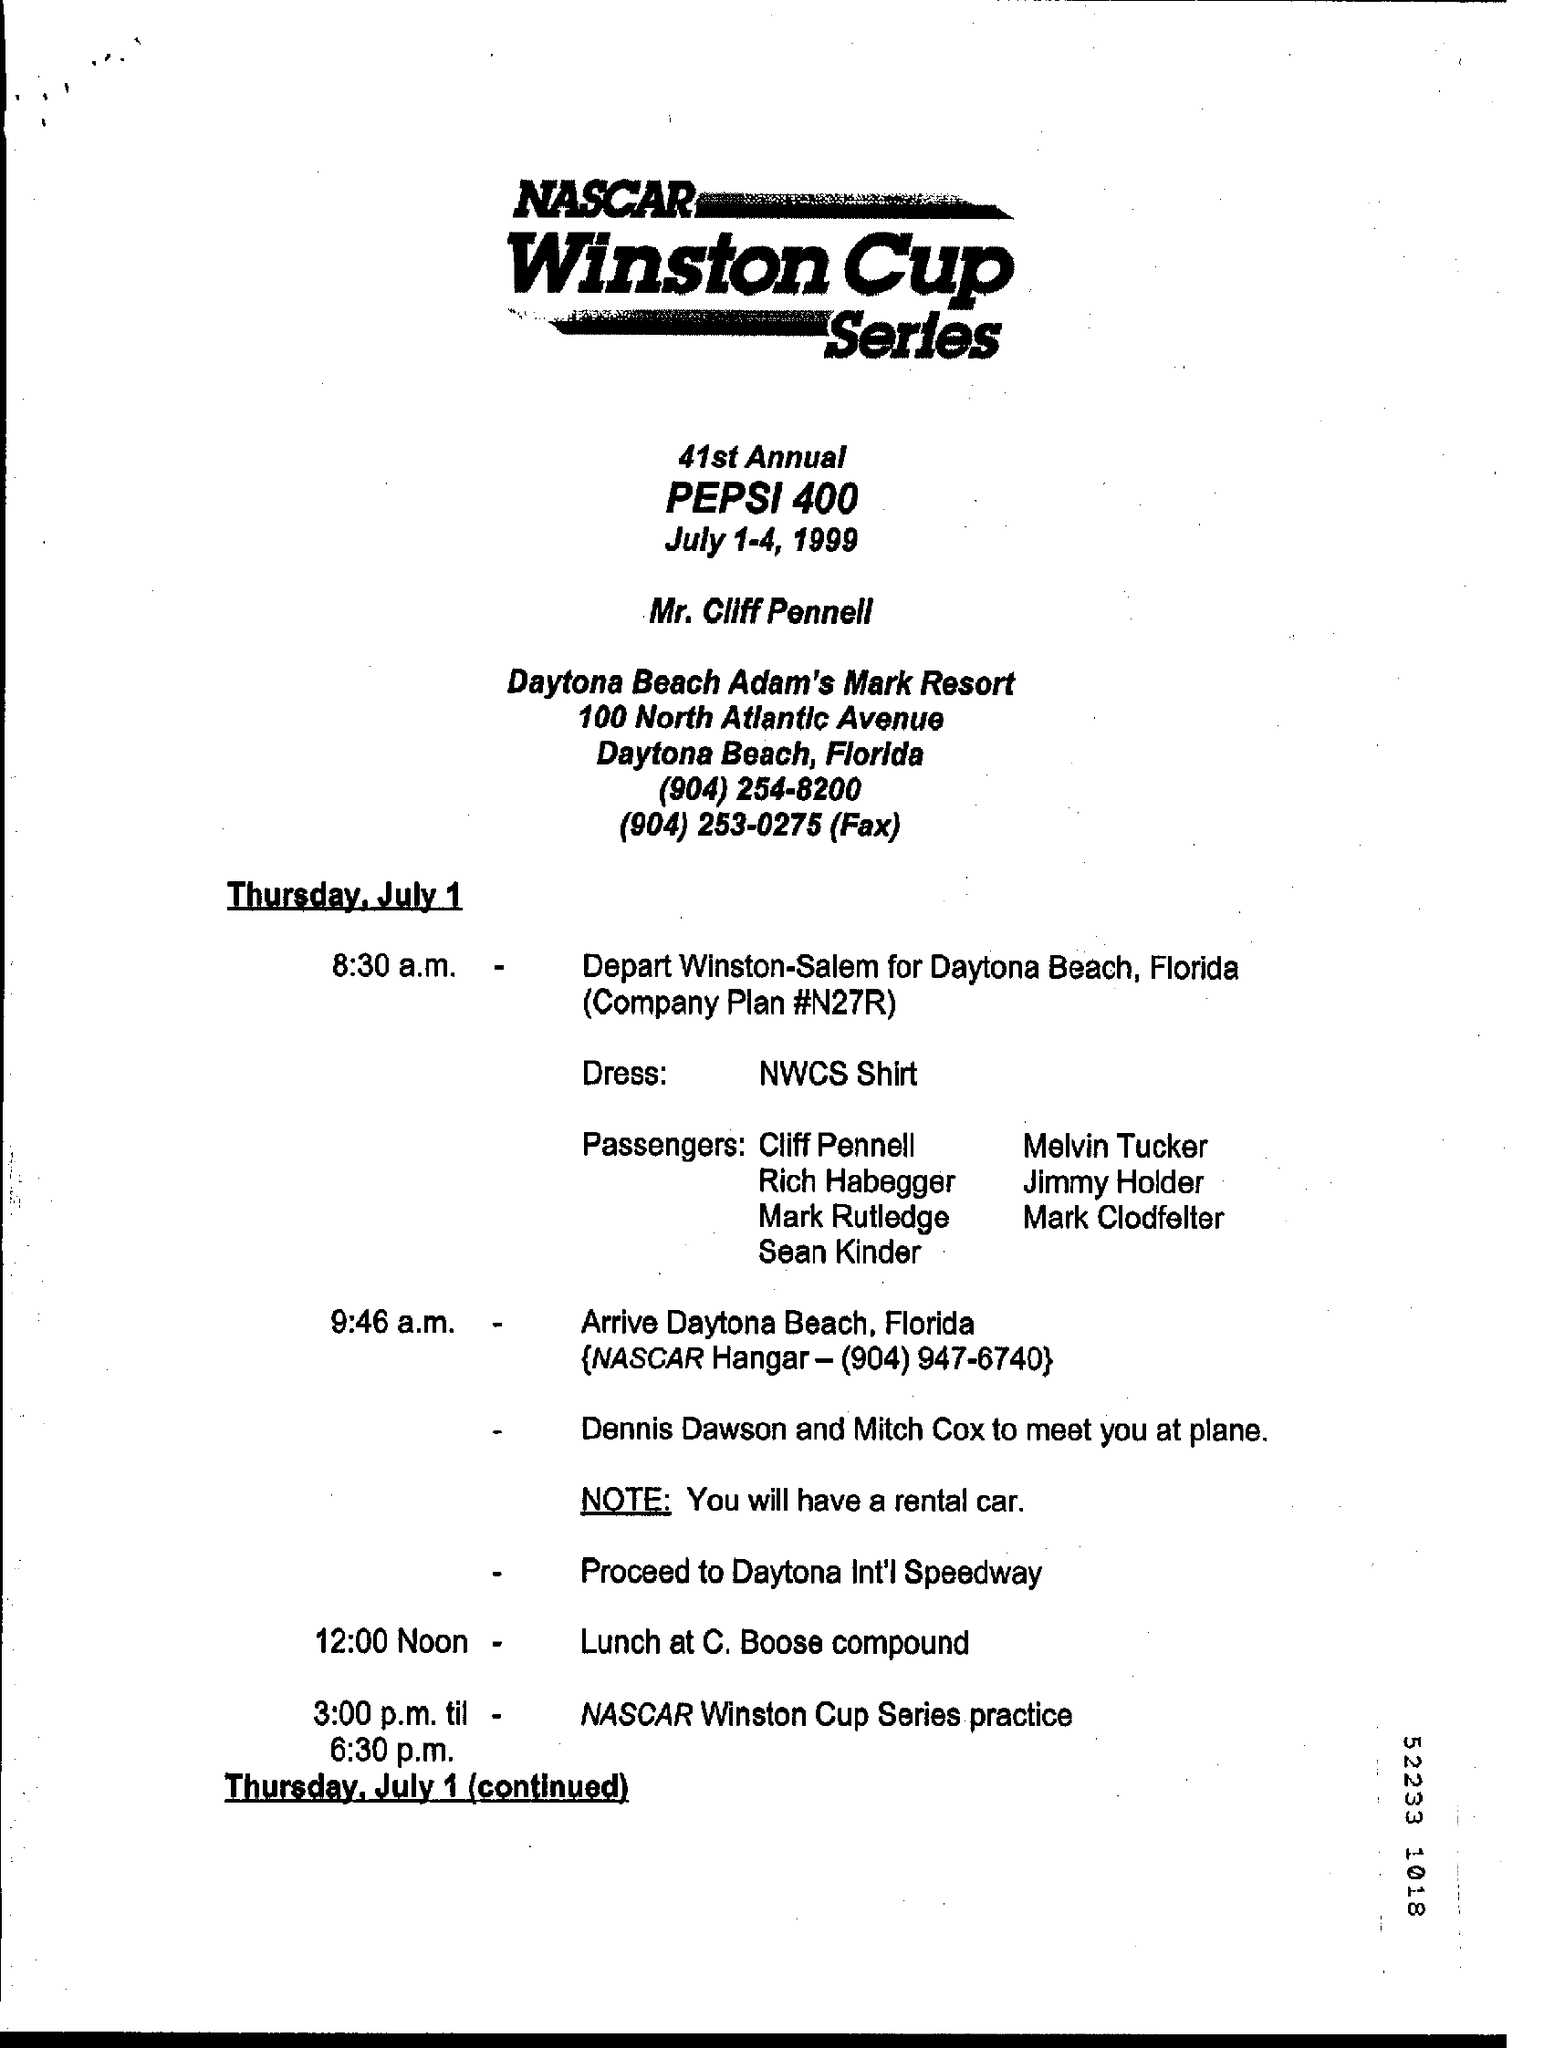Indicate a few pertinent items in this graphic. The 41st Annual Pepsi 400 will be held from July 1st to July 4th, 1999. 